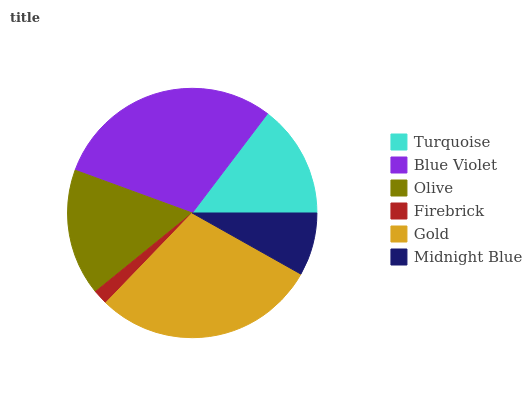Is Firebrick the minimum?
Answer yes or no. Yes. Is Blue Violet the maximum?
Answer yes or no. Yes. Is Olive the minimum?
Answer yes or no. No. Is Olive the maximum?
Answer yes or no. No. Is Blue Violet greater than Olive?
Answer yes or no. Yes. Is Olive less than Blue Violet?
Answer yes or no. Yes. Is Olive greater than Blue Violet?
Answer yes or no. No. Is Blue Violet less than Olive?
Answer yes or no. No. Is Olive the high median?
Answer yes or no. Yes. Is Turquoise the low median?
Answer yes or no. Yes. Is Turquoise the high median?
Answer yes or no. No. Is Gold the low median?
Answer yes or no. No. 